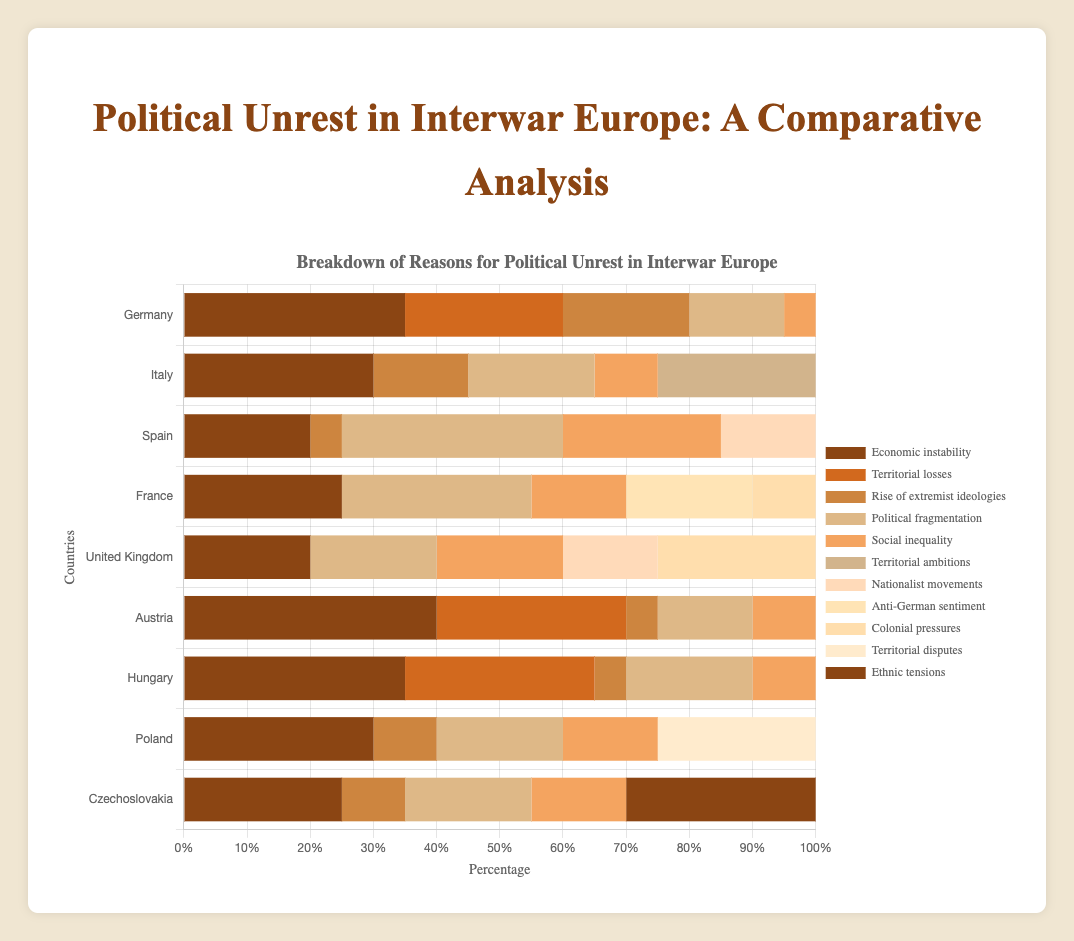Which country experienced the highest percentage of unrest due to economic instability? By observing the length of the bars representing "Economic instability" for each country, it is evident that Austria has the longest bar, indicating the highest percentage.
Answer: Austria Which two countries have the same percentage for the "Rise of extremist ideologies" reason? By comparing the bar lengths for "Rise of extremist ideologies," Germany and Hungary each show bars of the same length, representing 20% each.
Answer: Germany and Hungary How much more significant was "Economic instability" as a reason for unrest in Austria compared to Spain? The bar for "Economic instability" in Austria is 40% while in Spain it is 20%. The difference is calculated as 40% - 20% = 20%.
Answer: 20% Which reason for political unrest has the smallest percentage contribution in Germany? Observing the bars for Germany, the one with the smallest length represents "Social inequality" at 5%.
Answer: Social inequality On average, what percentage contribution does "Social inequality" have across all listed countries? Add up the percentages for "Social inequality" across all nine countries (5 + 10 + 25 + 15 + 20 + 10 + 10 + 15 + 15) which equals 125. Divide by 9 to get the average: 125 / 9 ≈ 13.89%.
Answer: 13.89% Which country shows a significant contribution from "Colonial pressures"? The visual inspection shows that France and the United Kingdom have substantial bars labeled "Colonial pressures," but the United Kingdom has a more significant contribution at 25%.
Answer: United Kingdom What is the total percentage contribution of "Political fragmentation" in France and Spain combined? France has 30% and Spain has 35% for "Political fragmentation." Add these together to get 30% + 35% = 65%.
Answer: 65% Which country has a higher percentage of "Territorial losses" as a reason for unrest, Germany or Austria? By comparing the lengths of the bars labeled "Territorial losses," Austria's bar is longer (30%) than Germany's (25%).
Answer: Austria In which country does "Nationalist movements" represent a significant cause of unrest? From the chart, the bar labeled "Nationalist movements" is only present in Spain (15%) and the United Kingdom (15%), thus both countries show it as a significant reason.
Answer: Spain and United Kingdom 